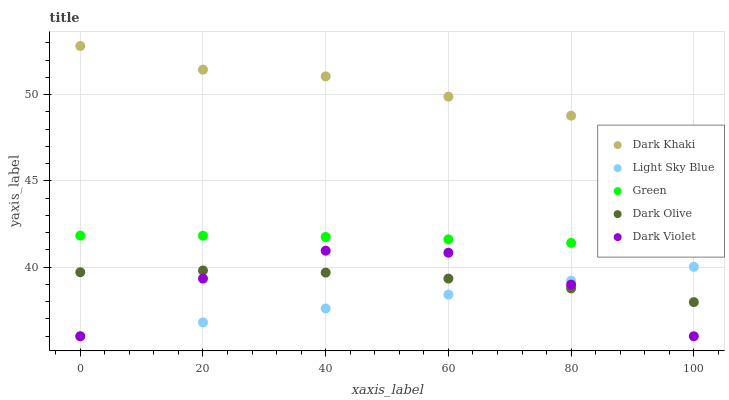Does Light Sky Blue have the minimum area under the curve?
Answer yes or no. Yes. Does Dark Khaki have the maximum area under the curve?
Answer yes or no. Yes. Does Dark Olive have the minimum area under the curve?
Answer yes or no. No. Does Dark Olive have the maximum area under the curve?
Answer yes or no. No. Is Light Sky Blue the smoothest?
Answer yes or no. Yes. Is Dark Violet the roughest?
Answer yes or no. Yes. Is Dark Olive the smoothest?
Answer yes or no. No. Is Dark Olive the roughest?
Answer yes or no. No. Does Light Sky Blue have the lowest value?
Answer yes or no. Yes. Does Dark Olive have the lowest value?
Answer yes or no. No. Does Dark Khaki have the highest value?
Answer yes or no. Yes. Does Light Sky Blue have the highest value?
Answer yes or no. No. Is Dark Olive less than Green?
Answer yes or no. Yes. Is Dark Khaki greater than Green?
Answer yes or no. Yes. Does Dark Violet intersect Dark Olive?
Answer yes or no. Yes. Is Dark Violet less than Dark Olive?
Answer yes or no. No. Is Dark Violet greater than Dark Olive?
Answer yes or no. No. Does Dark Olive intersect Green?
Answer yes or no. No. 